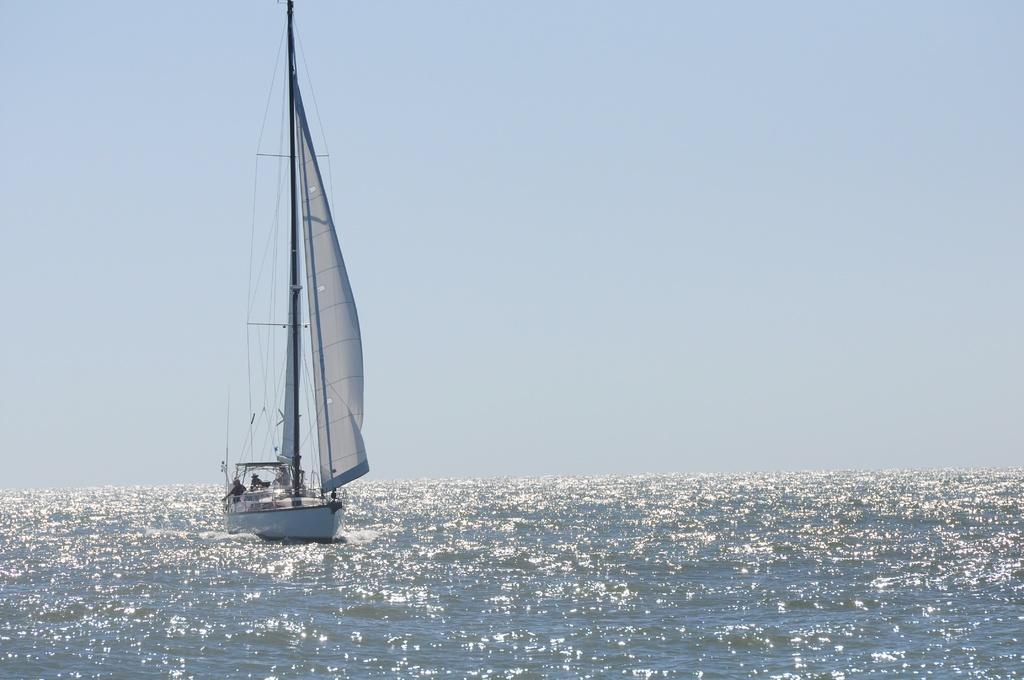Please provide a concise description of this image. In the image there is a boat sailing on the water surface, it has a huge mast. 